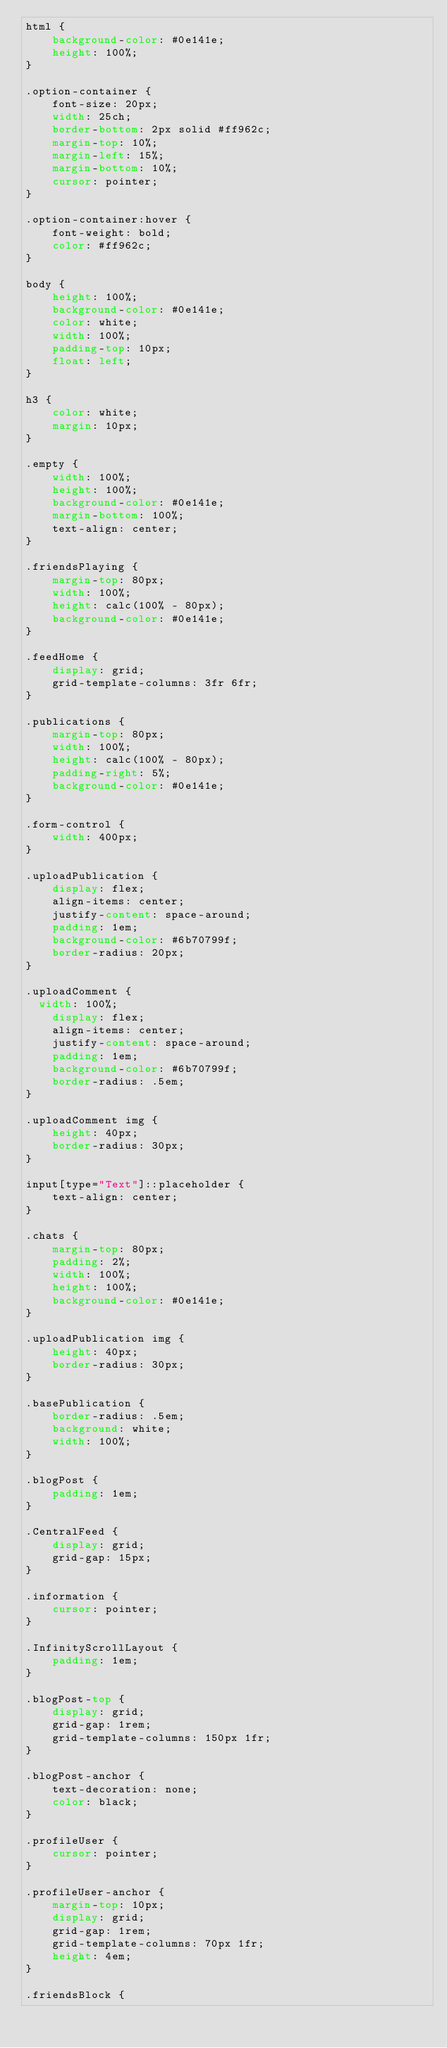<code> <loc_0><loc_0><loc_500><loc_500><_CSS_>html {
    background-color: #0e141e;
    height: 100%;
}

.option-container {
    font-size: 20px;
    width: 25ch;
    border-bottom: 2px solid #ff962c;
    margin-top: 10%;
    margin-left: 15%;
    margin-bottom: 10%;
    cursor: pointer;
}

.option-container:hover {
    font-weight: bold;
    color: #ff962c;
}

body {
    height: 100%;
    background-color: #0e141e;
    color: white;
    width: 100%;
    padding-top: 10px;
    float: left;
}

h3 {
    color: white;
    margin: 10px;
}

.empty {
    width: 100%;
    height: 100%;
    background-color: #0e141e;
    margin-bottom: 100%;
    text-align: center;
}

.friendsPlaying {
    margin-top: 80px;
    width: 100%;
    height: calc(100% - 80px);
    background-color: #0e141e;
}

.feedHome {
    display: grid;
    grid-template-columns: 3fr 6fr;
}

.publications {
    margin-top: 80px;
    width: 100%;
    height: calc(100% - 80px);
    padding-right: 5%;
    background-color: #0e141e;
}

.form-control {
    width: 400px;
}

.uploadPublication {
    display: flex;
    align-items: center;
    justify-content: space-around;
    padding: 1em;
    background-color: #6b70799f;
    border-radius: 20px;
}

.uploadComment {
  width: 100%;
    display: flex;
    align-items: center;
    justify-content: space-around;
    padding: 1em;
    background-color: #6b70799f;
    border-radius: .5em;
}

.uploadComment img {
    height: 40px;
    border-radius: 30px;
}

input[type="Text"]::placeholder {
    text-align: center;
}

.chats {
    margin-top: 80px;
    padding: 2%;
    width: 100%;
    height: 100%;
    background-color: #0e141e;
}

.uploadPublication img {
    height: 40px;
    border-radius: 30px;
}

.basePublication {
    border-radius: .5em;
    background: white;
    width: 100%;
}

.blogPost {
    padding: 1em;
}

.CentralFeed {
    display: grid;
    grid-gap: 15px;
}

.information {
    cursor: pointer;
}

.InfinityScrollLayout {
    padding: 1em;
}

.blogPost-top {
    display: grid;
    grid-gap: 1rem;
    grid-template-columns: 150px 1fr;
}

.blogPost-anchor {
    text-decoration: none;
    color: black;
}

.profileUser {
    cursor: pointer;
}

.profileUser-anchor {
    margin-top: 10px;
    display: grid;
    grid-gap: 1rem;
    grid-template-columns: 70px 1fr;
    height: 4em;
}

.friendsBlock {</code> 